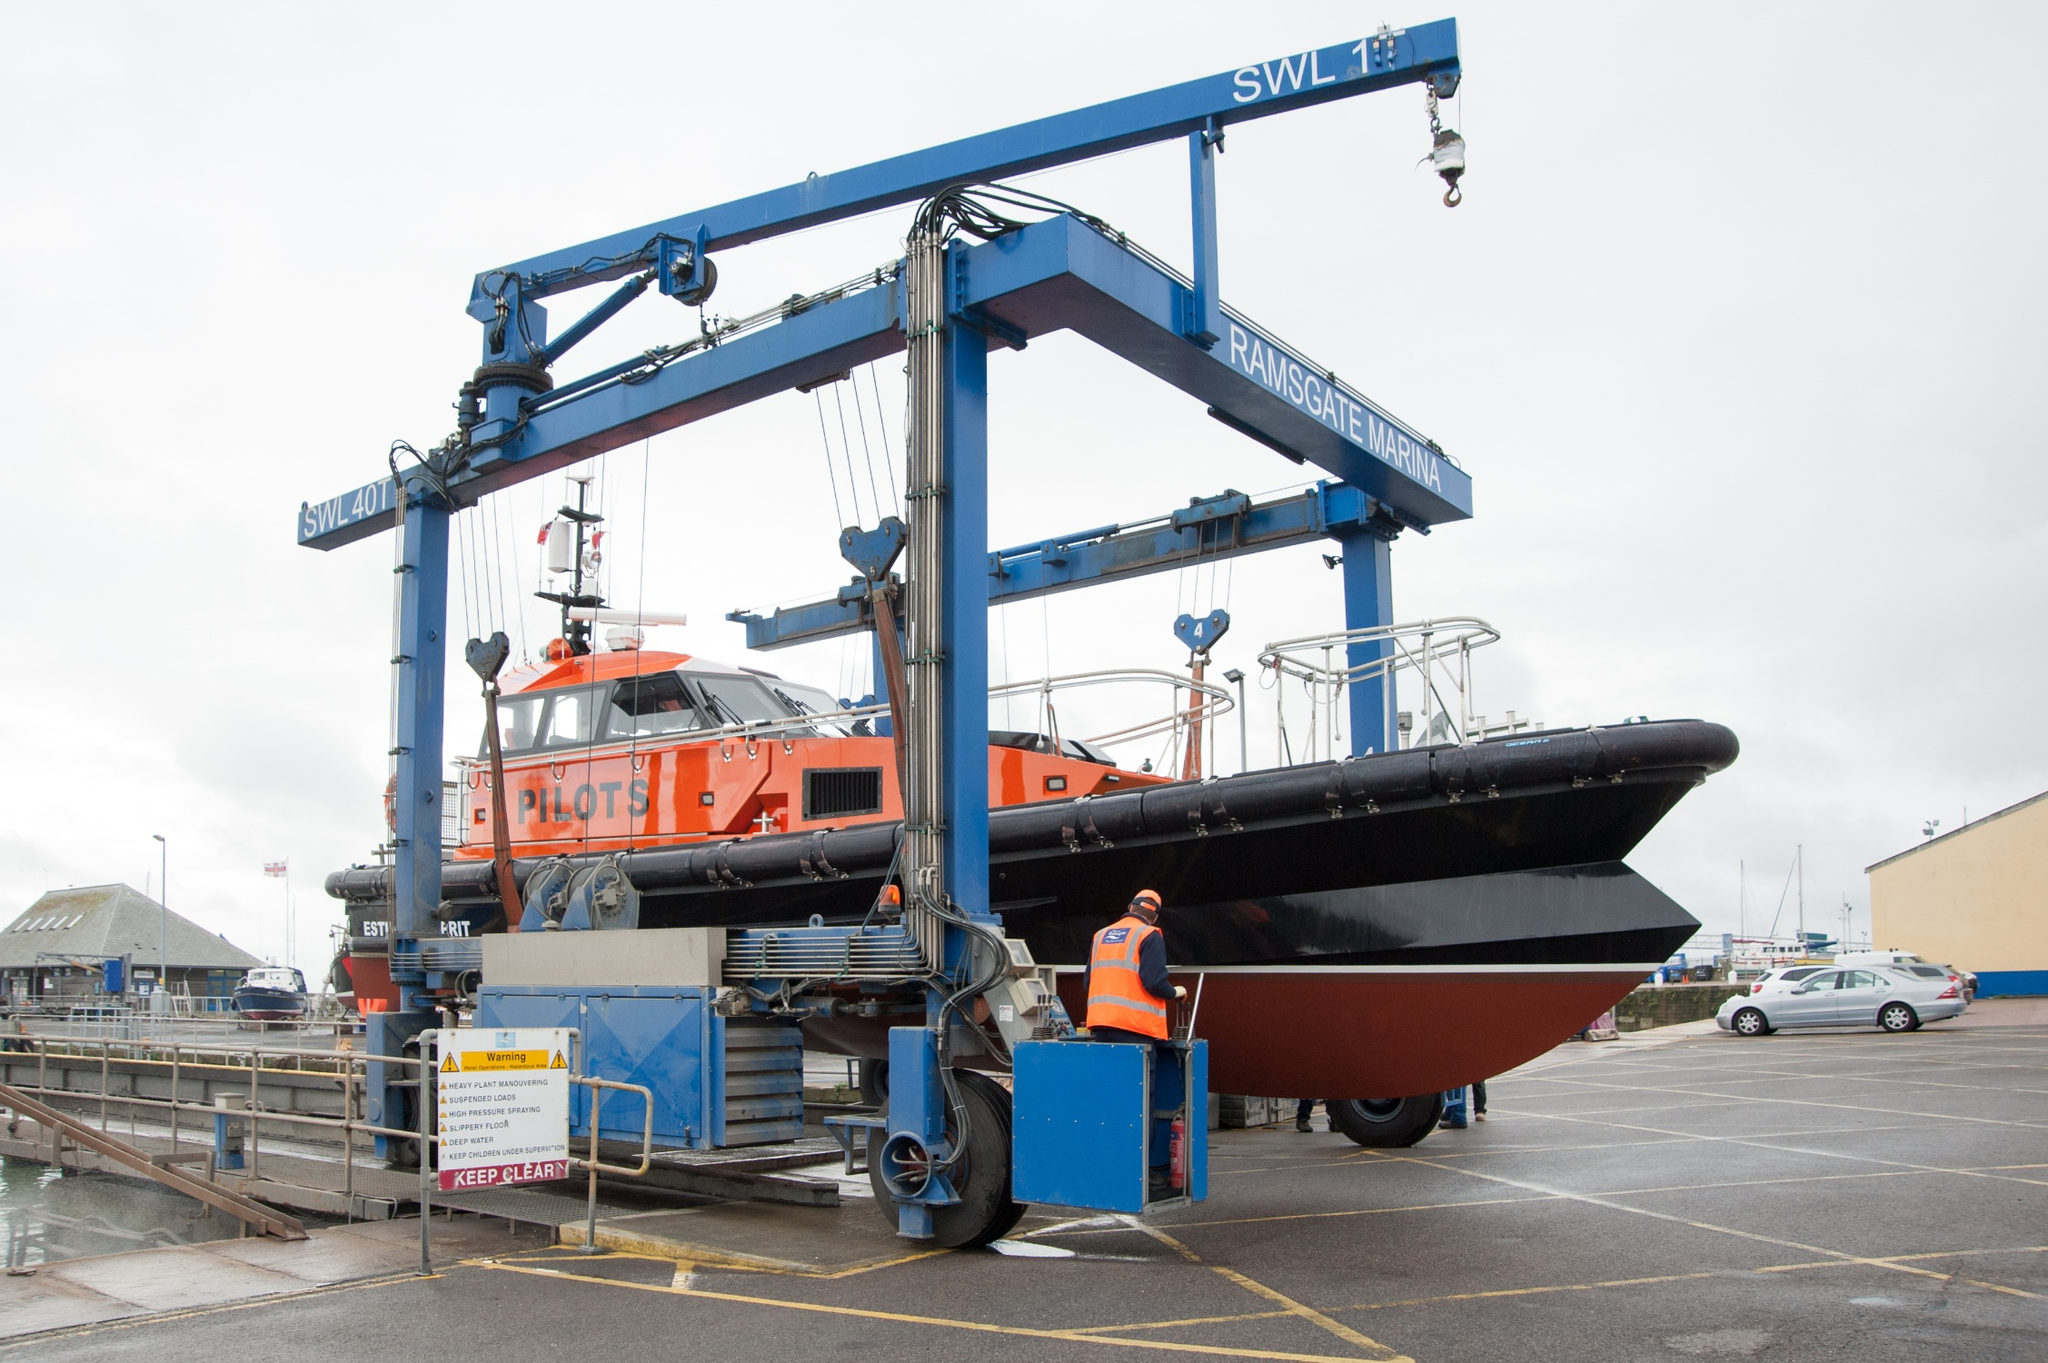What are the key elements in this picture? The image captures a bustling harbor scene dominated by a large blue crane, proudly bearing the name "Ransomes & Rapier" and a sign that reads "SWL 7t". This mechanical giant is in the midst of hoisting a black and orange pilot boat out of the water, its hull emblazoned with the word "PILOTS". The boat is suspended in mid-air, held aloft by several sturdy cables attached to the crane.

In the background, a few cars and buildings can be seen, providing a sense of scale and context to the scene. The colors are vibrant, with the blue of the crane and the orange of the boat creating a striking contrast. The perspective of the image gives a clear view of the crane's operation, showcasing the impressive feat of lifting such a large boat out of the water.

As for the landmark identification "sa_14374", I'm afraid I couldn't find specific information related to it in my current knowledge and search results. It might be a code or identifier specific to a certain system or database. If you have more context or details about it, I'd be glad to help further! 